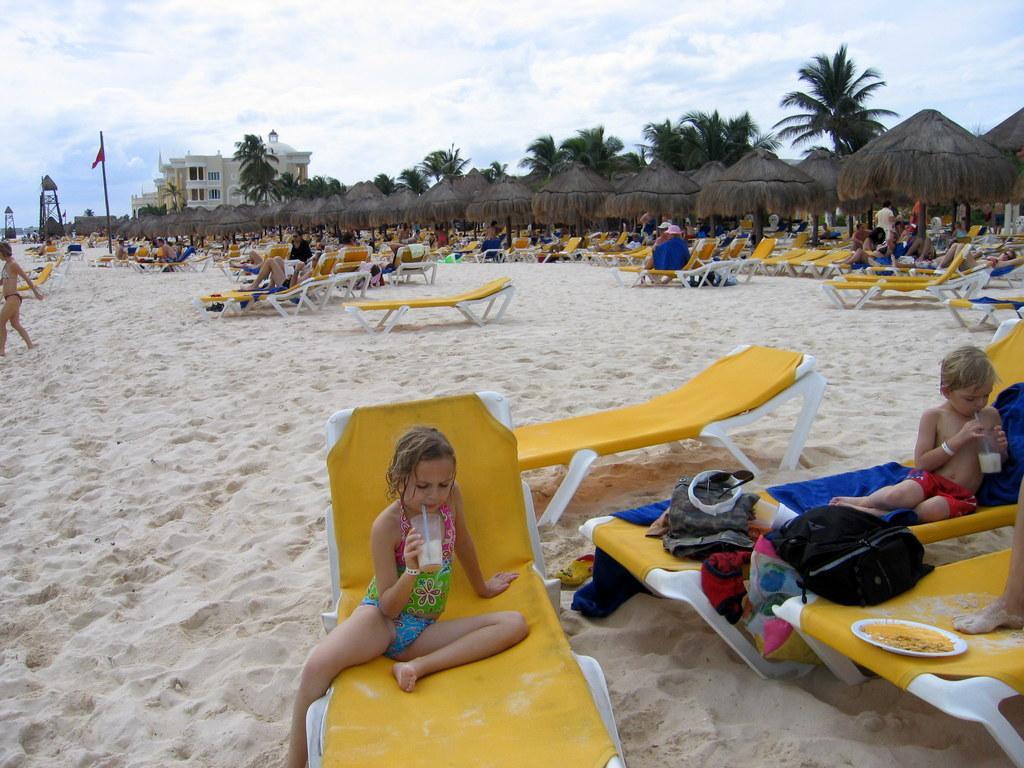Could you give a brief overview of what you see in this image? This picture shows a seashore. We see few people seated on the chairs and we see bags and couple of kids holding glasses in their hands and drinking and we see food in the plate and we see a pole flag and a building and trees and huts and we see a blue cloudy sky. 